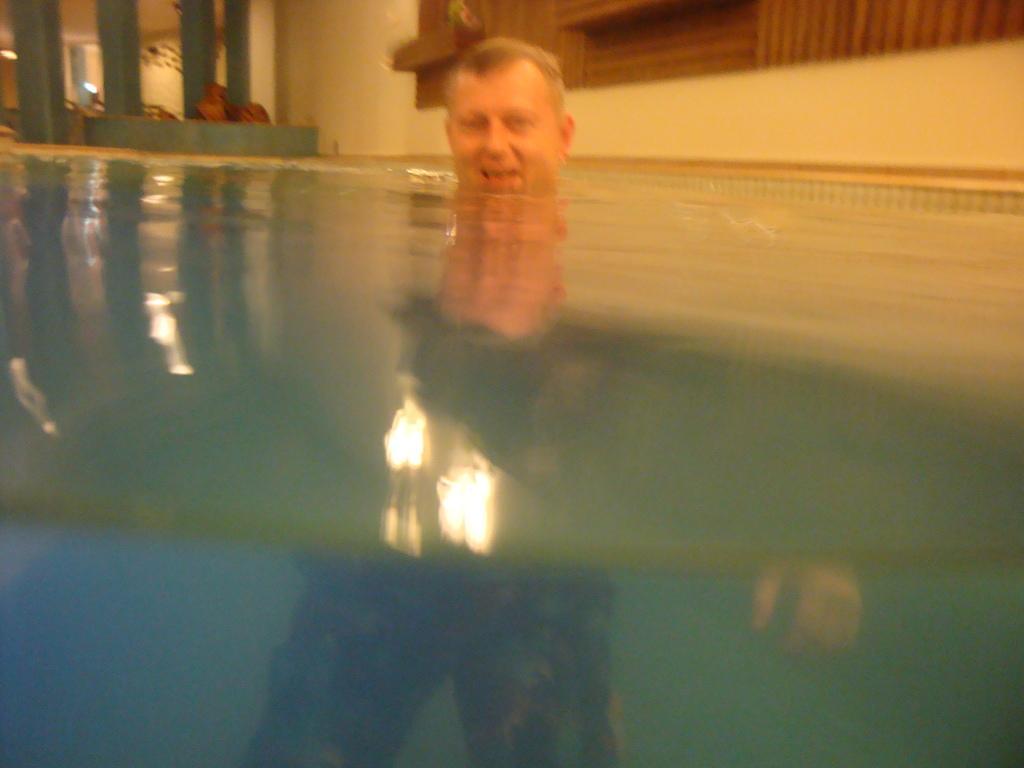Can you describe this image briefly? In this image, in the middle, we can see a man drowning in the water. On the left side, we can see a grill window. On the right side, we can see a frame which is attached to a wall. 